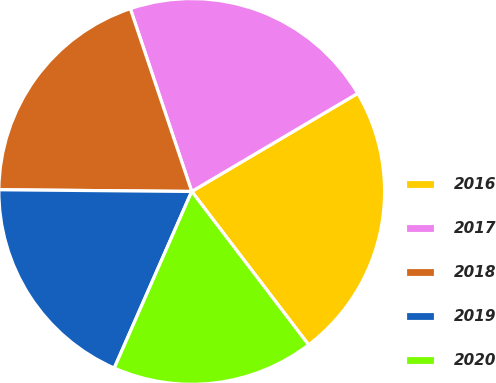Convert chart to OTSL. <chart><loc_0><loc_0><loc_500><loc_500><pie_chart><fcel>2016<fcel>2017<fcel>2018<fcel>2019<fcel>2020<nl><fcel>23.13%<fcel>21.66%<fcel>19.7%<fcel>18.56%<fcel>16.94%<nl></chart> 